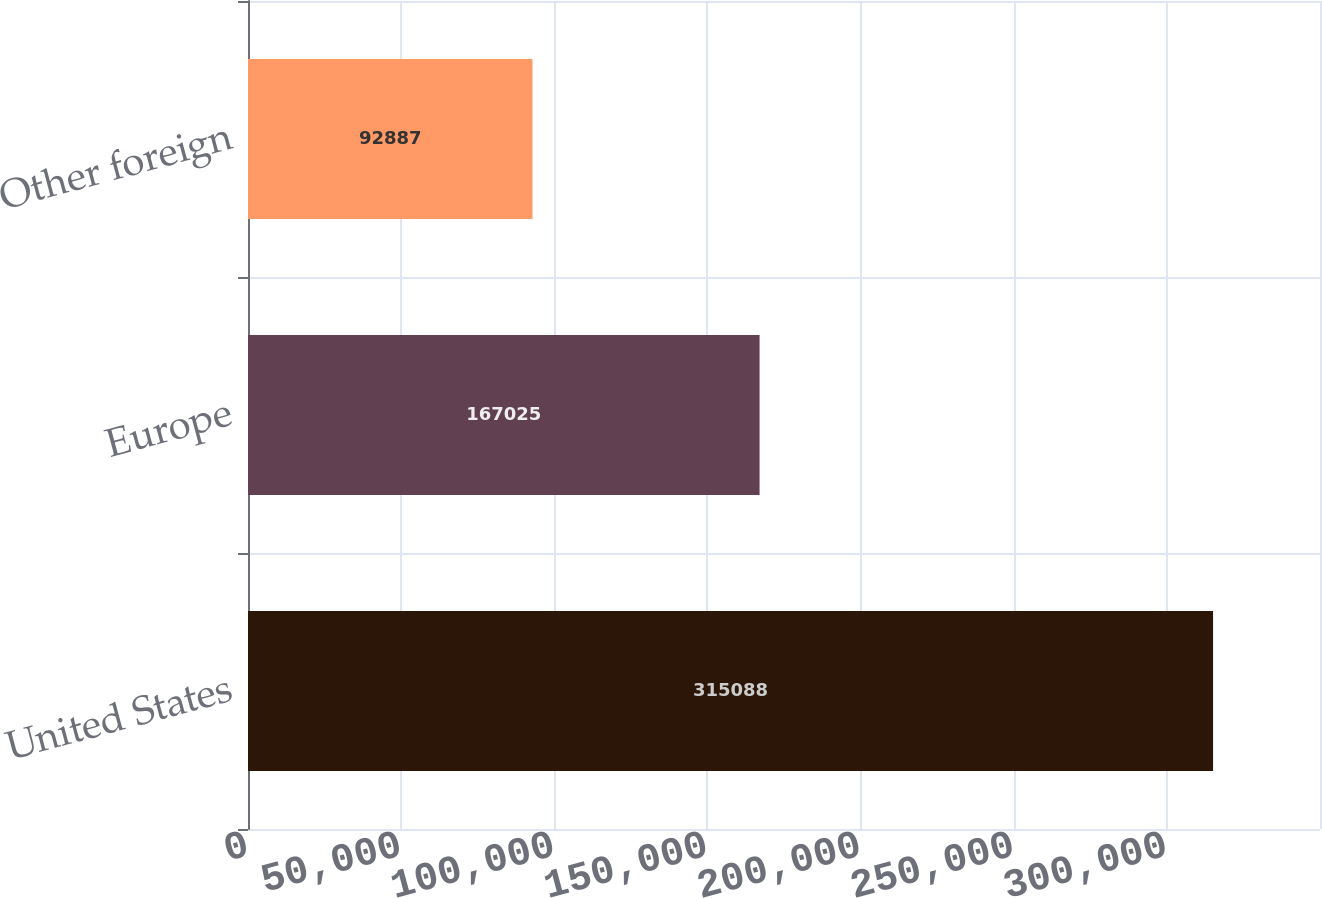<chart> <loc_0><loc_0><loc_500><loc_500><bar_chart><fcel>United States<fcel>Europe<fcel>Other foreign<nl><fcel>315088<fcel>167025<fcel>92887<nl></chart> 